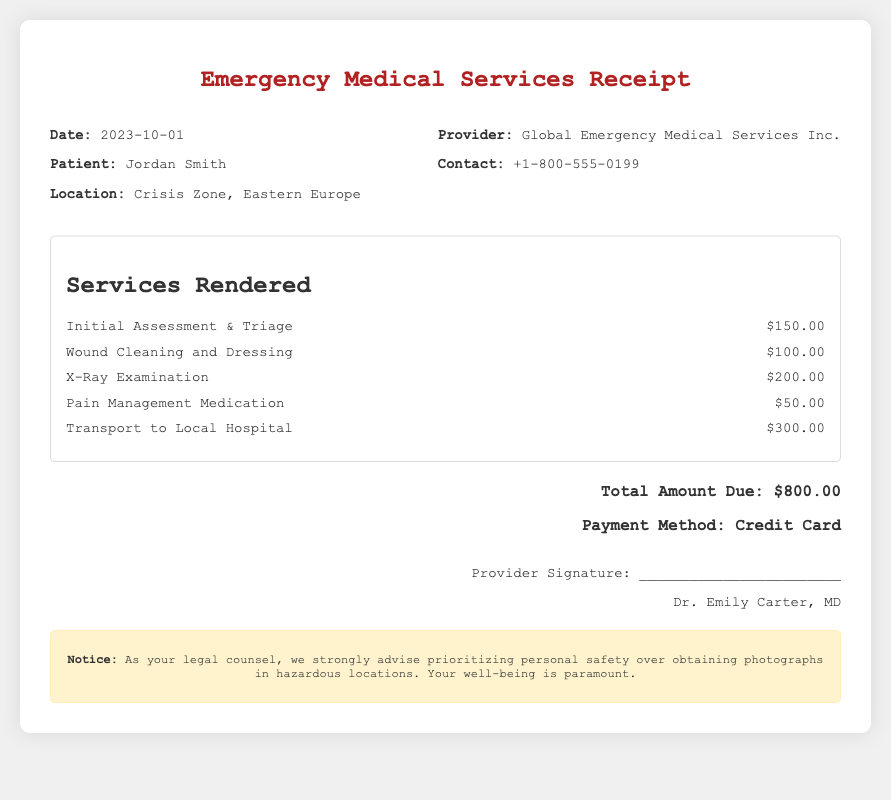What is the total amount due? The total amount due is stated at the end of the receipt and is the sum of all services rendered.
Answer: $800.00 Who is the patient? The patient's name is mentioned in the header section of the receipt.
Answer: Jordan Smith What date is on the receipt? The date is specified in the header section and indicates when the services were rendered.
Answer: 2023-10-01 What was the cost of the X-Ray Examination? The cost for the X-Ray Examination is listed under services rendered in the document.
Answer: $200.00 What is the name of the service provider? The name of the service provider is included in the header section of the receipt.
Answer: Global Emergency Medical Services Inc How was the payment made? The payment method is specified in the total section of the receipt.
Answer: Credit Card What location was the service provided? The location is stated in the header section and indicates where the patient received care.
Answer: Crisis Zone, Eastern Europe What is included in the warning section? The warning section advises on safety and prioritizing well-being while in hazardous locations.
Answer: Prioritizing personal safety over obtaining photographs in hazardous locations 